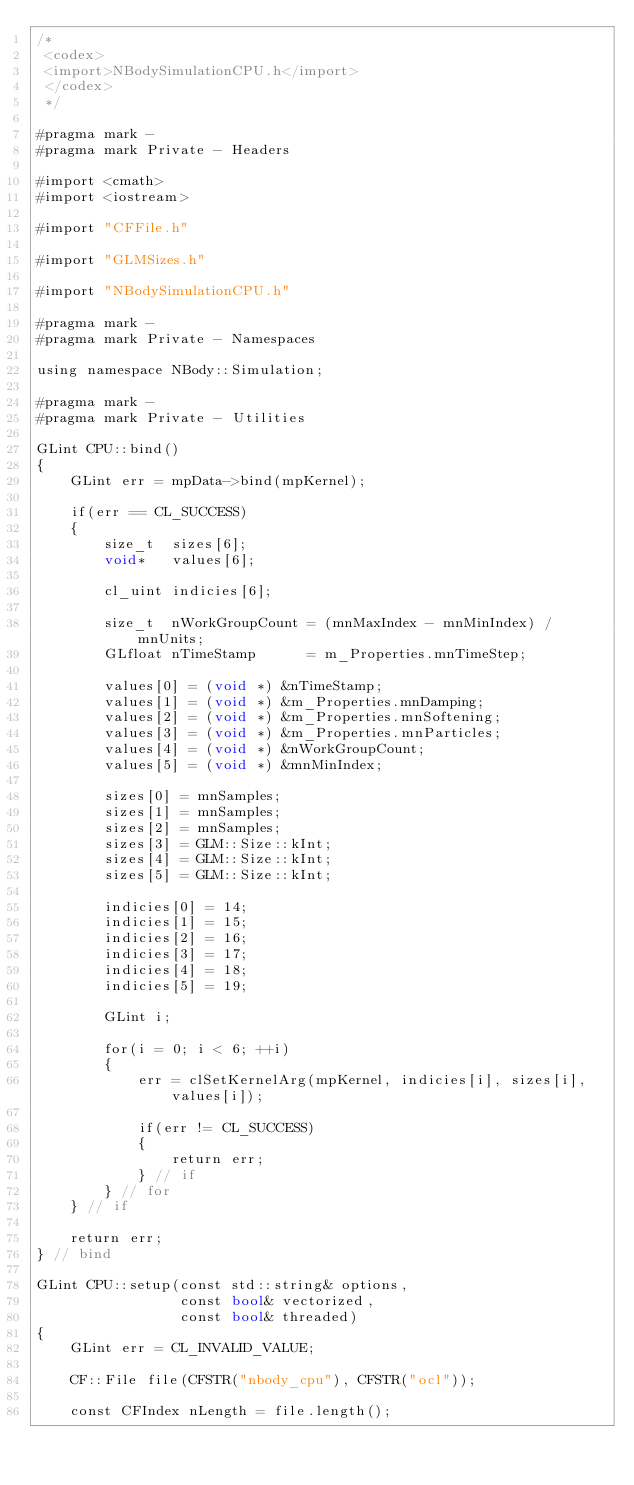Convert code to text. <code><loc_0><loc_0><loc_500><loc_500><_ObjectiveC_>/*
 <codex>
 <import>NBodySimulationCPU.h</import>
 </codex>
 */

#pragma mark -
#pragma mark Private - Headers

#import <cmath>
#import <iostream>

#import "CFFile.h"

#import "GLMSizes.h"

#import "NBodySimulationCPU.h"

#pragma mark -
#pragma mark Private - Namespaces

using namespace NBody::Simulation;

#pragma mark -
#pragma mark Private - Utilities

GLint CPU::bind()
{
    GLint err = mpData->bind(mpKernel);
    
    if(err == CL_SUCCESS)
    {
        size_t  sizes[6];
        void*   values[6];
        
        cl_uint indicies[6];
        
        size_t  nWorkGroupCount = (mnMaxIndex - mnMinIndex) / mnUnits;
        GLfloat nTimeStamp      = m_Properties.mnTimeStep;
        
        values[0] = (void *) &nTimeStamp;
        values[1] = (void *) &m_Properties.mnDamping;
        values[2] = (void *) &m_Properties.mnSoftening;
        values[3] = (void *) &m_Properties.mnParticles;
        values[4] = (void *) &nWorkGroupCount;
        values[5] = (void *) &mnMinIndex;
        
        sizes[0] = mnSamples;
        sizes[1] = mnSamples;
        sizes[2] = mnSamples;
        sizes[3] = GLM::Size::kInt;
        sizes[4] = GLM::Size::kInt;
        sizes[5] = GLM::Size::kInt;
        
        indicies[0] = 14;
        indicies[1] = 15;
        indicies[2] = 16;
        indicies[3] = 17;
        indicies[4] = 18;
        indicies[5] = 19;
        
        GLint i;
        
        for(i = 0; i < 6; ++i)
        {
            err = clSetKernelArg(mpKernel, indicies[i], sizes[i], values[i]);
            
            if(err != CL_SUCCESS)
            {
                return err;
            } // if
        } // for
    } // if
    
    return err;
} // bind

GLint CPU::setup(const std::string& options,
                 const bool& vectorized,
                 const bool& threaded)
{
    GLint err = CL_INVALID_VALUE;
    
    CF::File file(CFSTR("nbody_cpu"), CFSTR("ocl"));
    
    const CFIndex nLength = file.length();</code> 